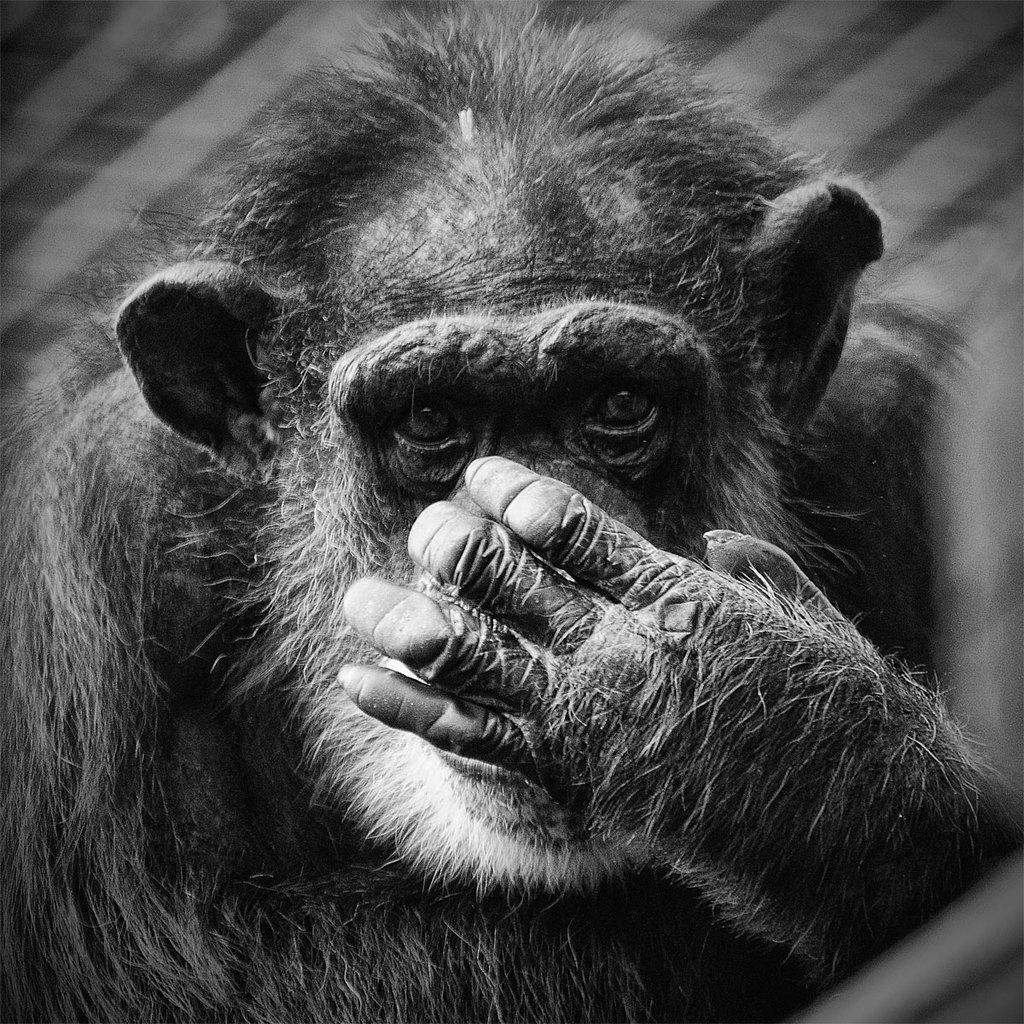What animal is in the picture? There is a monkey in the picture. What color is the monkey's fur? The monkey has black fur. What is the monkey doing with its hand? The monkey is closing its nose with its hand. What type of stitch is the monkey using to sew a pencil in the image? There is no stitch or pencil present in the image; the monkey is simply closing its nose with its hand. 